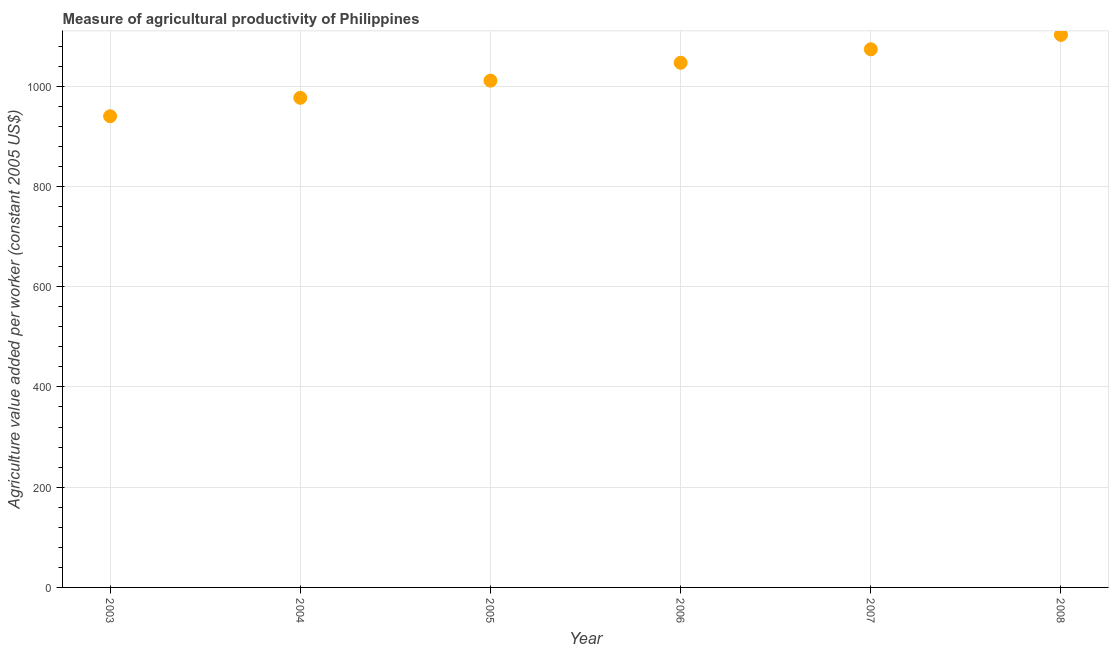What is the agriculture value added per worker in 2004?
Provide a succinct answer. 976.69. Across all years, what is the maximum agriculture value added per worker?
Keep it short and to the point. 1102.19. Across all years, what is the minimum agriculture value added per worker?
Offer a very short reply. 939.93. In which year was the agriculture value added per worker maximum?
Your answer should be very brief. 2008. In which year was the agriculture value added per worker minimum?
Your answer should be very brief. 2003. What is the sum of the agriculture value added per worker?
Offer a terse response. 6149.76. What is the difference between the agriculture value added per worker in 2005 and 2006?
Offer a terse response. -35.68. What is the average agriculture value added per worker per year?
Your answer should be very brief. 1024.96. What is the median agriculture value added per worker?
Provide a short and direct response. 1028.74. Do a majority of the years between 2005 and 2004 (inclusive) have agriculture value added per worker greater than 320 US$?
Your response must be concise. No. What is the ratio of the agriculture value added per worker in 2003 to that in 2007?
Make the answer very short. 0.88. What is the difference between the highest and the second highest agriculture value added per worker?
Your answer should be compact. 28.73. Is the sum of the agriculture value added per worker in 2004 and 2006 greater than the maximum agriculture value added per worker across all years?
Make the answer very short. Yes. What is the difference between the highest and the lowest agriculture value added per worker?
Offer a terse response. 162.27. In how many years, is the agriculture value added per worker greater than the average agriculture value added per worker taken over all years?
Your response must be concise. 3. How many dotlines are there?
Give a very brief answer. 1. How many years are there in the graph?
Provide a succinct answer. 6. What is the difference between two consecutive major ticks on the Y-axis?
Your answer should be very brief. 200. Are the values on the major ticks of Y-axis written in scientific E-notation?
Your answer should be compact. No. What is the title of the graph?
Provide a succinct answer. Measure of agricultural productivity of Philippines. What is the label or title of the X-axis?
Make the answer very short. Year. What is the label or title of the Y-axis?
Offer a terse response. Agriculture value added per worker (constant 2005 US$). What is the Agriculture value added per worker (constant 2005 US$) in 2003?
Provide a succinct answer. 939.93. What is the Agriculture value added per worker (constant 2005 US$) in 2004?
Your response must be concise. 976.69. What is the Agriculture value added per worker (constant 2005 US$) in 2005?
Keep it short and to the point. 1010.9. What is the Agriculture value added per worker (constant 2005 US$) in 2006?
Your response must be concise. 1046.58. What is the Agriculture value added per worker (constant 2005 US$) in 2007?
Your answer should be compact. 1073.46. What is the Agriculture value added per worker (constant 2005 US$) in 2008?
Offer a very short reply. 1102.19. What is the difference between the Agriculture value added per worker (constant 2005 US$) in 2003 and 2004?
Your answer should be compact. -36.76. What is the difference between the Agriculture value added per worker (constant 2005 US$) in 2003 and 2005?
Provide a short and direct response. -70.98. What is the difference between the Agriculture value added per worker (constant 2005 US$) in 2003 and 2006?
Ensure brevity in your answer.  -106.66. What is the difference between the Agriculture value added per worker (constant 2005 US$) in 2003 and 2007?
Give a very brief answer. -133.53. What is the difference between the Agriculture value added per worker (constant 2005 US$) in 2003 and 2008?
Provide a short and direct response. -162.27. What is the difference between the Agriculture value added per worker (constant 2005 US$) in 2004 and 2005?
Offer a terse response. -34.21. What is the difference between the Agriculture value added per worker (constant 2005 US$) in 2004 and 2006?
Ensure brevity in your answer.  -69.89. What is the difference between the Agriculture value added per worker (constant 2005 US$) in 2004 and 2007?
Give a very brief answer. -96.77. What is the difference between the Agriculture value added per worker (constant 2005 US$) in 2004 and 2008?
Your response must be concise. -125.5. What is the difference between the Agriculture value added per worker (constant 2005 US$) in 2005 and 2006?
Give a very brief answer. -35.68. What is the difference between the Agriculture value added per worker (constant 2005 US$) in 2005 and 2007?
Your response must be concise. -62.55. What is the difference between the Agriculture value added per worker (constant 2005 US$) in 2005 and 2008?
Your answer should be compact. -91.29. What is the difference between the Agriculture value added per worker (constant 2005 US$) in 2006 and 2007?
Give a very brief answer. -26.88. What is the difference between the Agriculture value added per worker (constant 2005 US$) in 2006 and 2008?
Provide a short and direct response. -55.61. What is the difference between the Agriculture value added per worker (constant 2005 US$) in 2007 and 2008?
Your answer should be very brief. -28.73. What is the ratio of the Agriculture value added per worker (constant 2005 US$) in 2003 to that in 2004?
Keep it short and to the point. 0.96. What is the ratio of the Agriculture value added per worker (constant 2005 US$) in 2003 to that in 2006?
Ensure brevity in your answer.  0.9. What is the ratio of the Agriculture value added per worker (constant 2005 US$) in 2003 to that in 2007?
Offer a terse response. 0.88. What is the ratio of the Agriculture value added per worker (constant 2005 US$) in 2003 to that in 2008?
Your answer should be very brief. 0.85. What is the ratio of the Agriculture value added per worker (constant 2005 US$) in 2004 to that in 2005?
Your answer should be compact. 0.97. What is the ratio of the Agriculture value added per worker (constant 2005 US$) in 2004 to that in 2006?
Offer a terse response. 0.93. What is the ratio of the Agriculture value added per worker (constant 2005 US$) in 2004 to that in 2007?
Offer a terse response. 0.91. What is the ratio of the Agriculture value added per worker (constant 2005 US$) in 2004 to that in 2008?
Your answer should be very brief. 0.89. What is the ratio of the Agriculture value added per worker (constant 2005 US$) in 2005 to that in 2006?
Your answer should be compact. 0.97. What is the ratio of the Agriculture value added per worker (constant 2005 US$) in 2005 to that in 2007?
Make the answer very short. 0.94. What is the ratio of the Agriculture value added per worker (constant 2005 US$) in 2005 to that in 2008?
Ensure brevity in your answer.  0.92. 